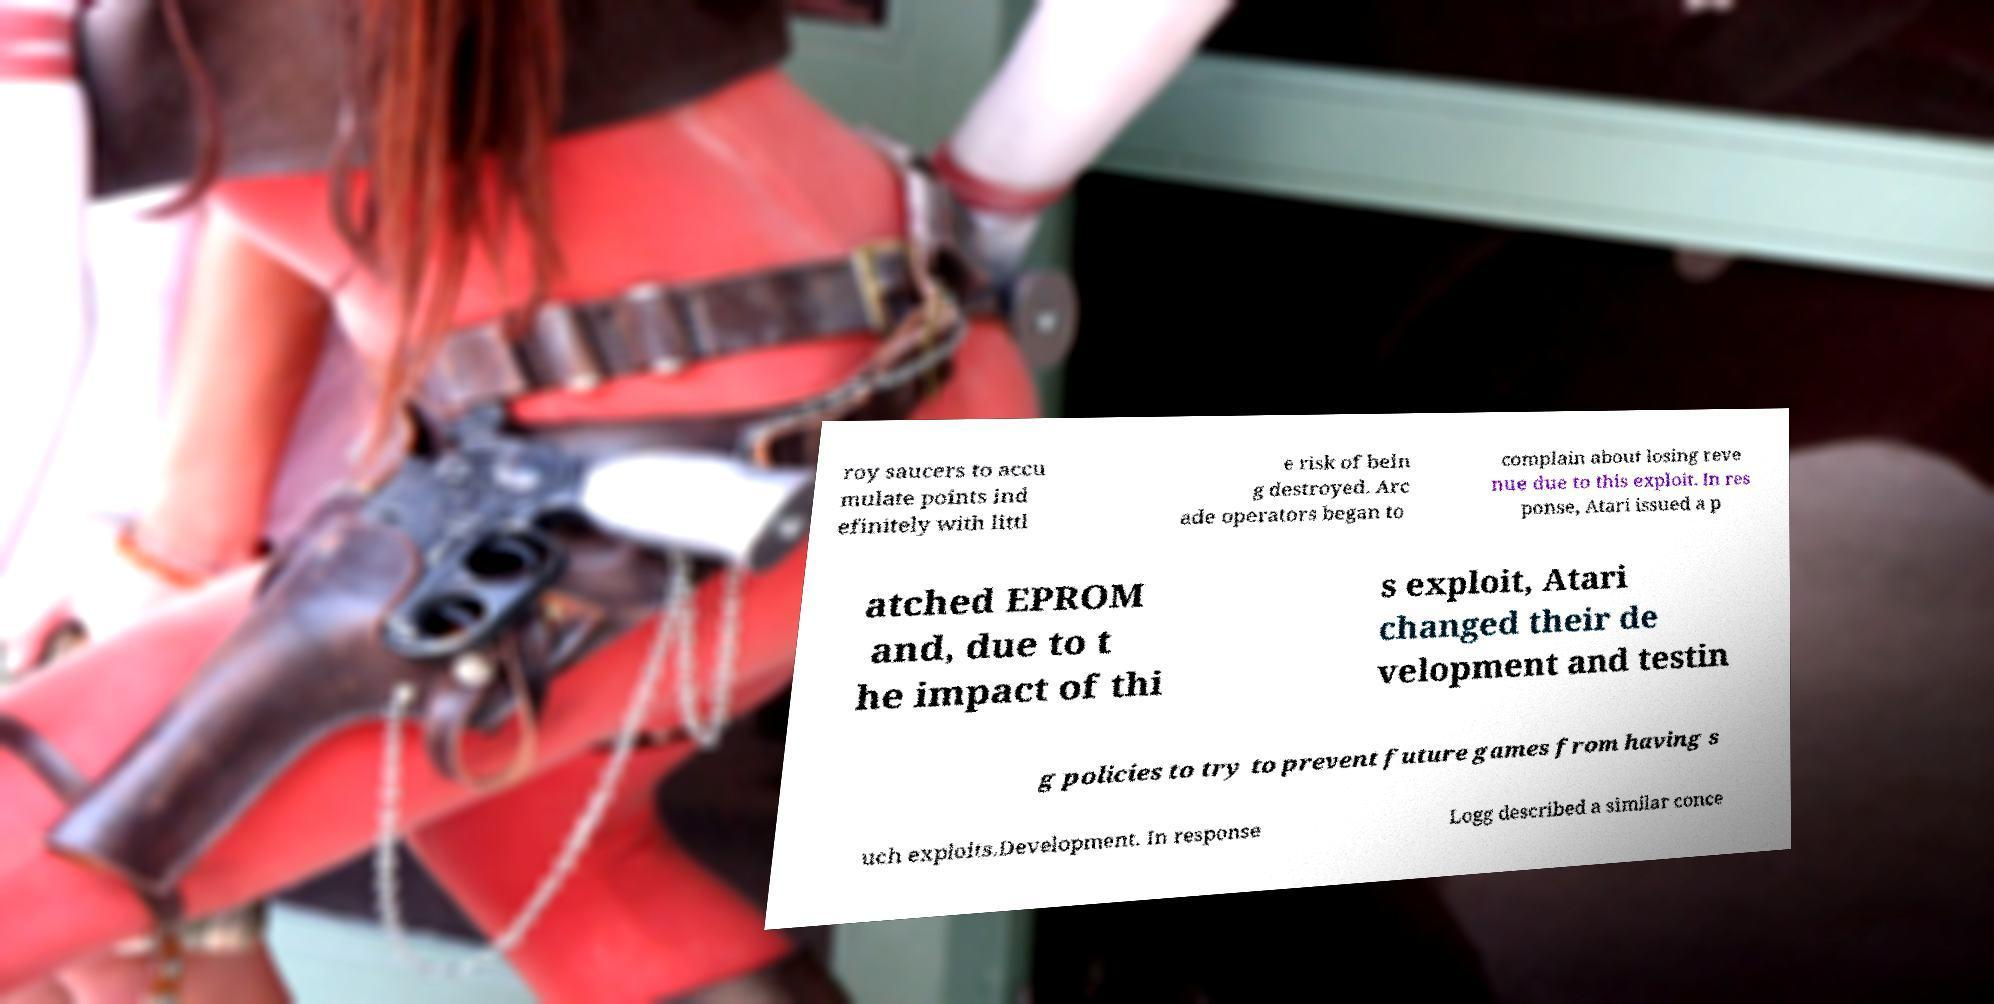Could you assist in decoding the text presented in this image and type it out clearly? roy saucers to accu mulate points ind efinitely with littl e risk of bein g destroyed. Arc ade operators began to complain about losing reve nue due to this exploit. In res ponse, Atari issued a p atched EPROM and, due to t he impact of thi s exploit, Atari changed their de velopment and testin g policies to try to prevent future games from having s uch exploits.Development. In response Logg described a similar conce 